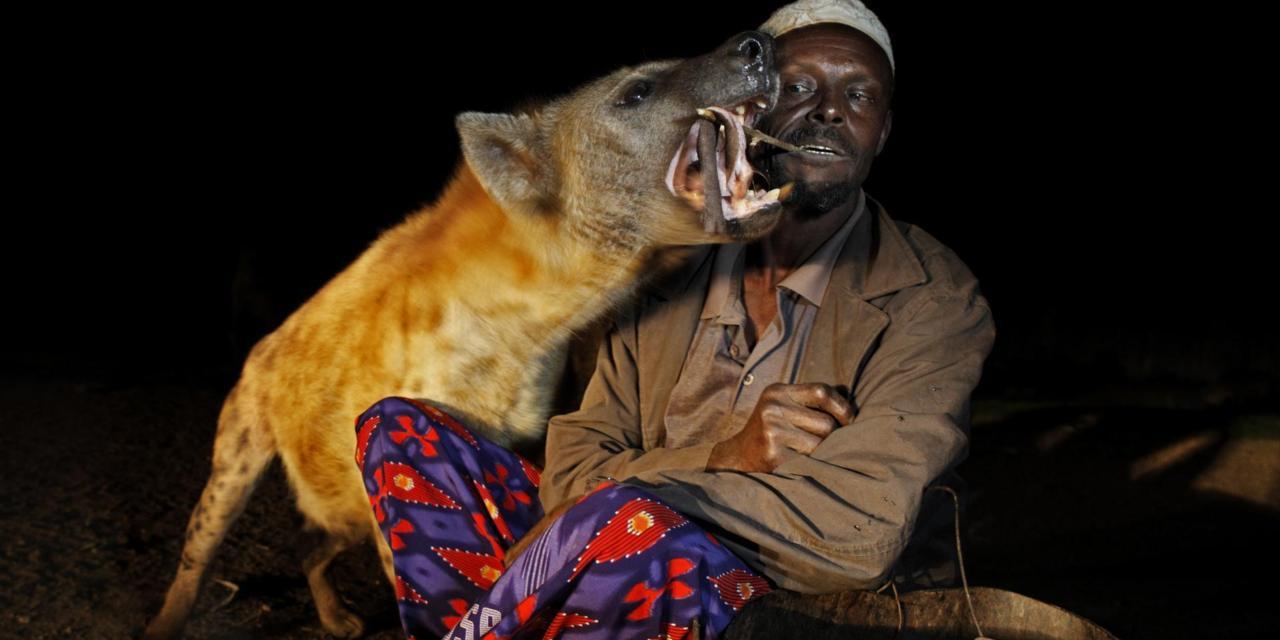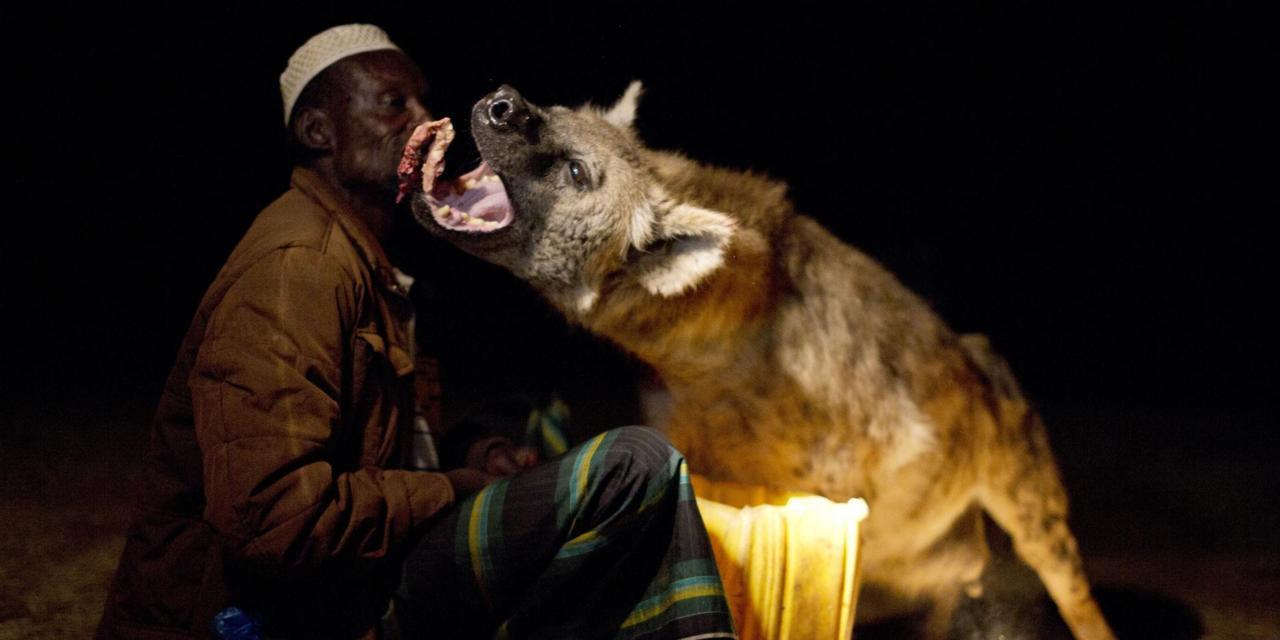The first image is the image on the left, the second image is the image on the right. Examine the images to the left and right. Is the description "There are two hyenas in total." accurate? Answer yes or no. Yes. The first image is the image on the left, the second image is the image on the right. Assess this claim about the two images: "The left image contains a human interacting with a hyena.". Correct or not? Answer yes or no. Yes. 